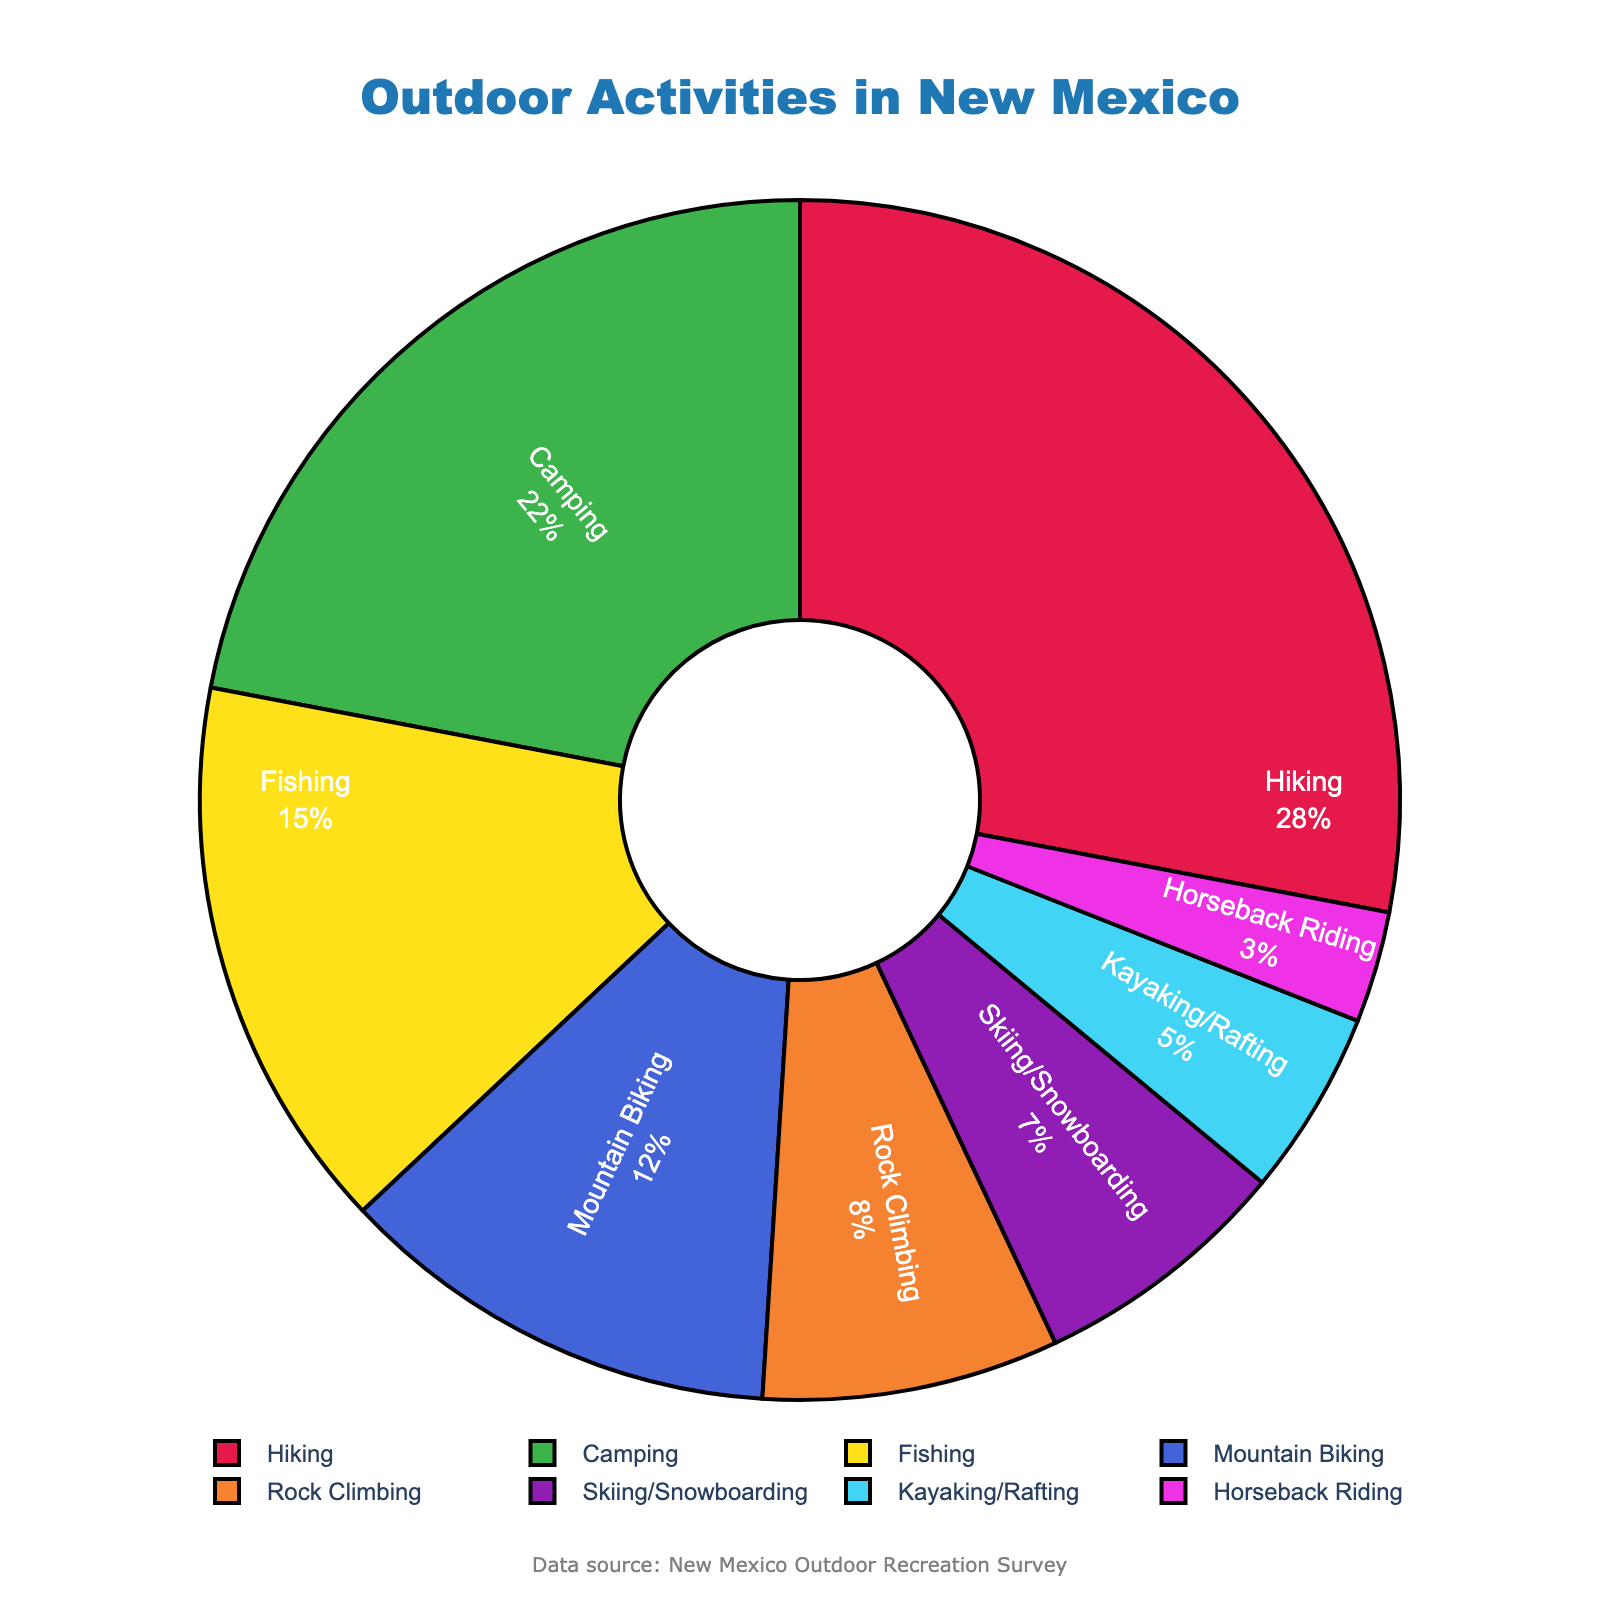What activity has the highest percentage of participation among New Mexico residents? The pie chart shows that Hiking has the largest section, indicating the highest percentage.
Answer: Hiking Which activities have a participation percentage of less than 10%? The pie chart segments for Rock Climbing, Skiing/Snowboarding, Kayaking/Rafting, and Horseback Riding are less than 10%.
Answer: Rock Climbing, Skiing/Snowboarding, Kayaking/Rafting, Horseback Riding What is the combined percentage of residents who participate in Skiing/Snowboarding and Kayaking/Rafting? The chart shows that Skiing/Snowboarding has 7% and Kayaking/Rafting has 5%. Adding these gives 7% + 5% = 12%.
Answer: 12% Which activity has a higher participation percentage: Fishing or Mountain Biking? From the chart, Fishing has 15% and Mountain Biking has 12%. Therefore, Fishing has a higher participation percentage.
Answer: Fishing What is the difference in participation percentage between the activity with the highest participation and the activity with the lowest participation? The highest participation is Hiking at 28%, and the lowest is Horseback Riding at 3%. The difference is 28% - 3% = 25%.
Answer: 25% Is there any activity that has a 5% participation rate? The chart shows that Kayaking/Rafting has a 5% participation rate.
Answer: Yes What percentage of New Mexico residents participate in either Rock Climbing or Horseback Riding? The chart shows Rock Climbing at 8% and Horseback Riding at 3%. Combined, this is 8% + 3% = 11%.
Answer: 11% Compare the percentages of Camping and Mountain Biking. Which is greater and by how much? Camping is at 22% and Mountain Biking is at 12%. Camping is greater by 22% - 12% = 10%.
Answer: Camping, by 10% What is the median value of the participation percentages? Ordering the percentages: 3, 5, 7, 8, 12, 15, 22, 28. The median is the average of the middle two values: (8 + 12) / 2 = 10.
Answer: 10 